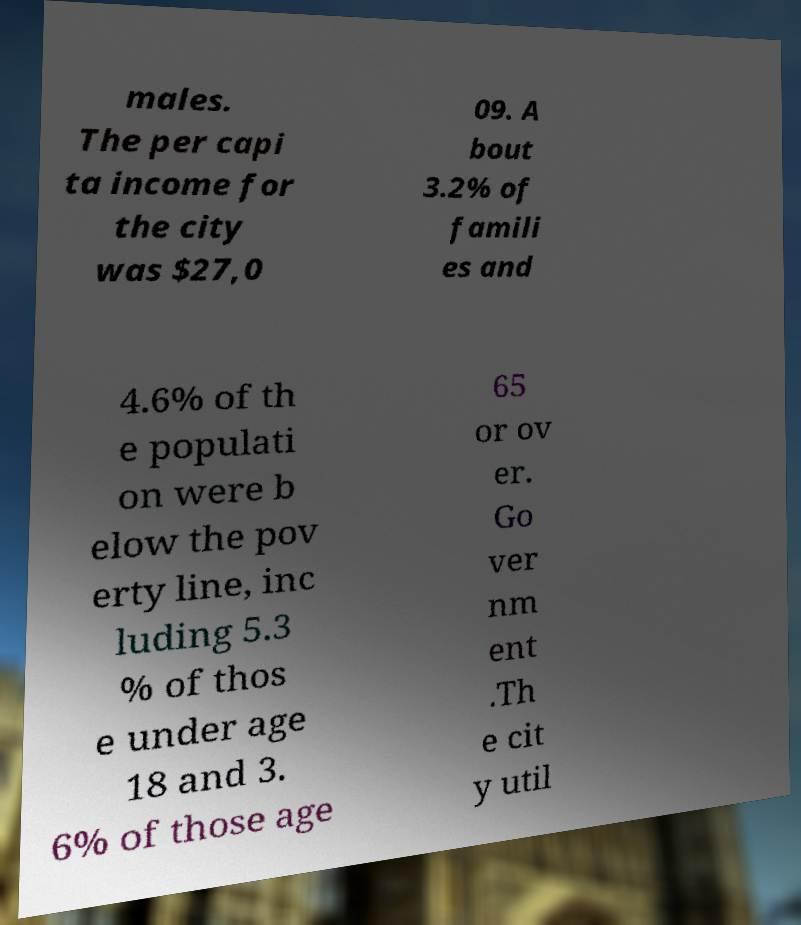What messages or text are displayed in this image? I need them in a readable, typed format. males. The per capi ta income for the city was $27,0 09. A bout 3.2% of famili es and 4.6% of th e populati on were b elow the pov erty line, inc luding 5.3 % of thos e under age 18 and 3. 6% of those age 65 or ov er. Go ver nm ent .Th e cit y util 